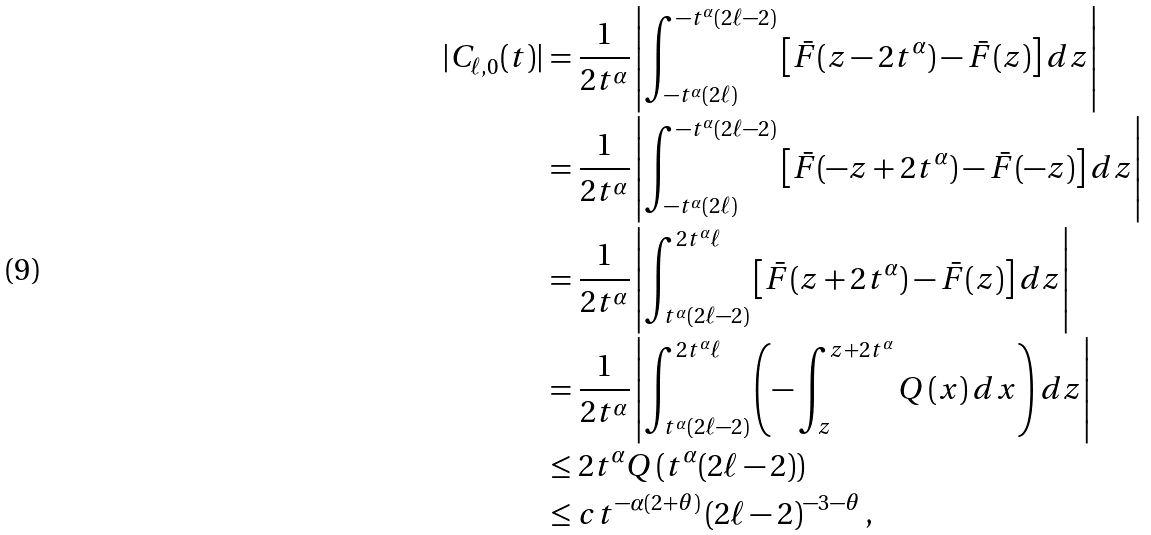Convert formula to latex. <formula><loc_0><loc_0><loc_500><loc_500>| C _ { \ell , 0 } ( t ) | & = \frac { 1 } { 2 t ^ { \alpha } } \left | \int _ { - t ^ { \alpha } ( 2 \ell ) } ^ { - t ^ { \alpha } ( 2 \ell - 2 ) } \left [ \bar { F } ( z - 2 t ^ { \alpha } ) - \bar { F } ( z ) \right ] d z \right | \\ & = \frac { 1 } { 2 t ^ { \alpha } } \left | \int _ { - t ^ { \alpha } ( 2 \ell ) } ^ { - t ^ { \alpha } ( 2 \ell - 2 ) } \left [ \bar { F } ( - z + 2 t ^ { \alpha } ) - \bar { F } ( - z ) \right ] d z \right | \\ & = \frac { 1 } { 2 t ^ { \alpha } } \left | \int _ { t ^ { \alpha } ( 2 \ell - 2 ) } ^ { 2 t ^ { \alpha } \ell } \left [ \bar { F } ( z + 2 t ^ { \alpha } ) - \bar { F } ( z ) \right ] d z \right | \\ & = \frac { 1 } { 2 t ^ { \alpha } } \left | \int _ { t ^ { \alpha } ( 2 \ell - 2 ) } ^ { 2 t ^ { \alpha } \ell } \left ( - \int _ { z } ^ { z + 2 t ^ { \alpha } } Q \left ( x \right ) d x \right ) d z \right | \\ & \leq 2 t ^ { \alpha } Q \left ( t ^ { \alpha } ( 2 \ell - 2 ) \right ) \\ & \leq c t ^ { - \alpha \left ( 2 + \theta \right ) } \left ( 2 \ell - 2 \right ) ^ { - 3 - \theta } ,</formula> 